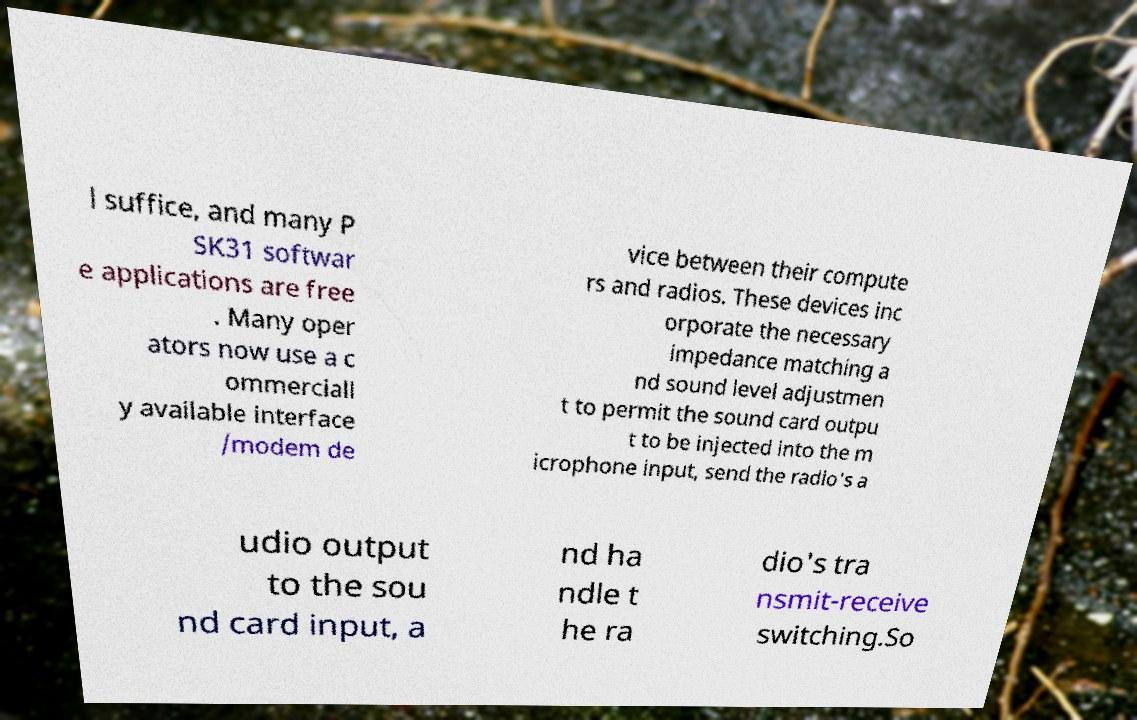Can you accurately transcribe the text from the provided image for me? l suffice, and many P SK31 softwar e applications are free . Many oper ators now use a c ommerciall y available interface /modem de vice between their compute rs and radios. These devices inc orporate the necessary impedance matching a nd sound level adjustmen t to permit the sound card outpu t to be injected into the m icrophone input, send the radio's a udio output to the sou nd card input, a nd ha ndle t he ra dio's tra nsmit-receive switching.So 